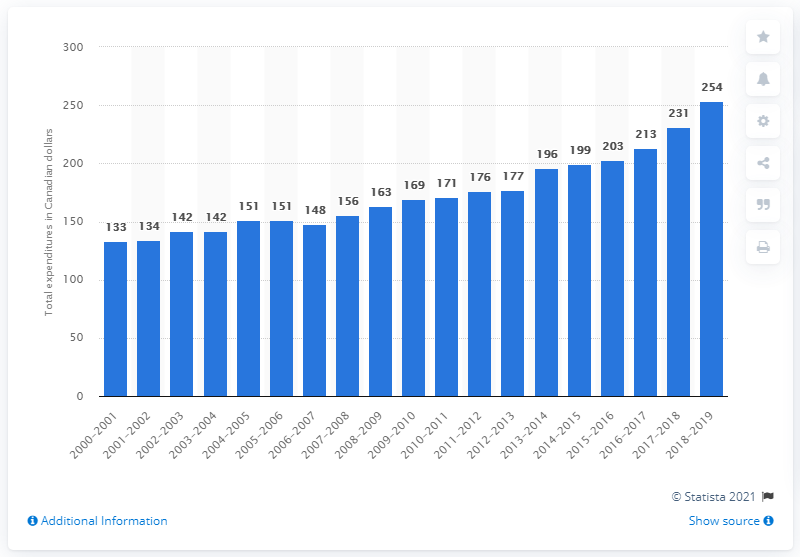Identify some key points in this picture. In the fiscal year of 2019, a total of 254 dollars were spent on inmates. 